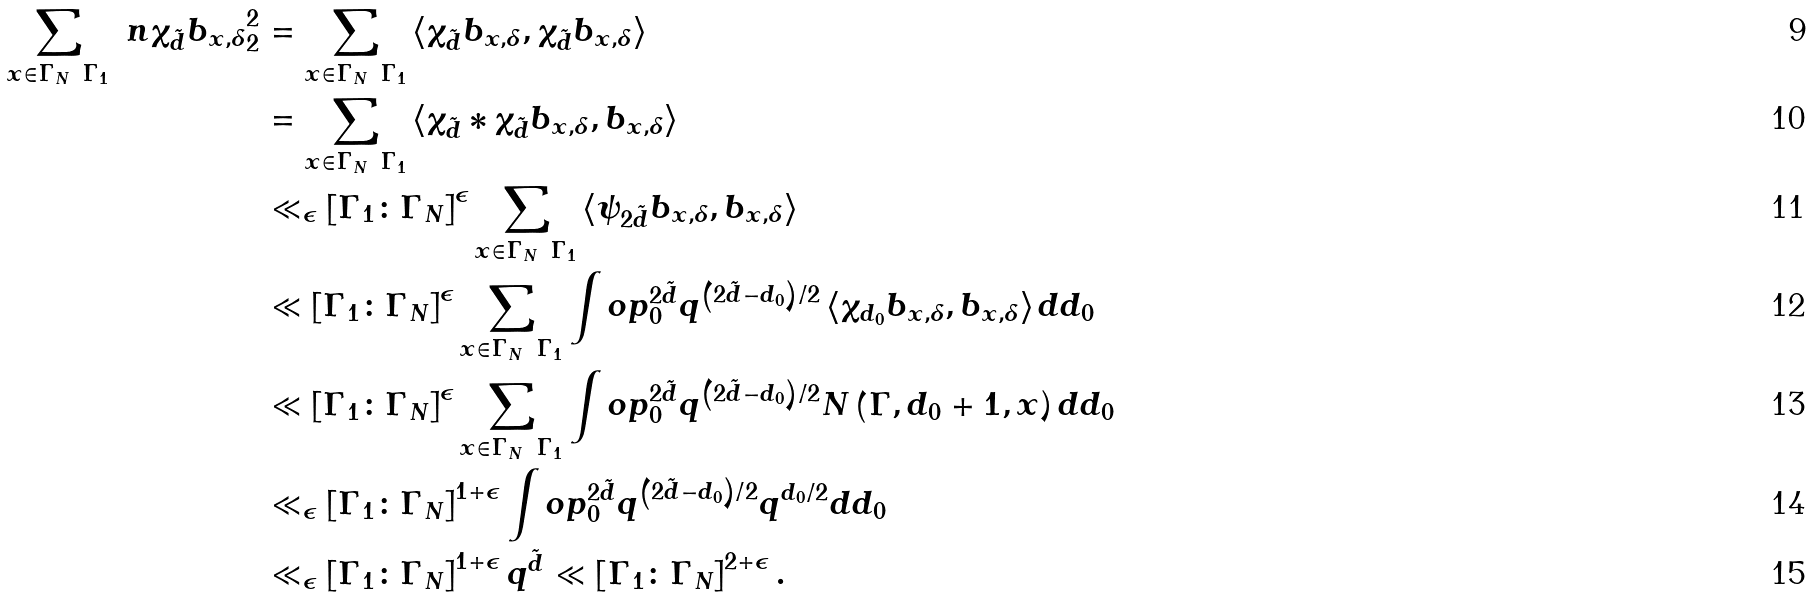<formula> <loc_0><loc_0><loc_500><loc_500>\sum _ { x \in \Gamma _ { N } \ \Gamma _ { 1 } } \ n { \chi _ { \tilde { d } } b _ { x , \delta } } _ { 2 } ^ { 2 } & = \sum _ { x \in \Gamma _ { N } \ \Gamma _ { 1 } } \left \langle \chi _ { \tilde { d } } b _ { x , \delta } , \chi _ { \tilde { d } } b _ { x , \delta } \right \rangle \\ & = \sum _ { x \in \Gamma _ { N } \ \Gamma _ { 1 } } \left \langle \chi _ { \tilde { d } } * \chi _ { \tilde { d } } b _ { x , \delta } , b _ { x , \delta } \right \rangle \\ & \ll _ { \epsilon } \left [ \Gamma _ { 1 } \colon \Gamma _ { N } \right ] ^ { \epsilon } \sum _ { x \in \Gamma _ { N } \ \Gamma _ { 1 } } \left \langle \psi _ { 2 \tilde { d } } b _ { x , \delta } , b _ { x , \delta } \right \rangle \\ & \ll \left [ \Gamma _ { 1 } \colon \Gamma _ { N } \right ] ^ { \epsilon } \sum _ { x \in \Gamma _ { N } \ \Gamma _ { 1 } } \int o p _ { 0 } ^ { 2 \tilde { d } } q ^ { \left ( 2 \tilde { d } - d _ { 0 } \right ) / 2 } \left \langle \chi _ { d _ { 0 } } b _ { x , \delta } , b _ { x , \delta } \right \rangle d d _ { 0 } \\ & \ll \left [ \Gamma _ { 1 } \colon \Gamma _ { N } \right ] ^ { \epsilon } \sum _ { x \in \Gamma _ { N } \ \Gamma _ { 1 } } \int o p _ { 0 } ^ { 2 \tilde { d } } q ^ { \left ( 2 \tilde { d } - d _ { 0 } \right ) / 2 } N \left ( \Gamma , d _ { 0 } + 1 , x \right ) d d _ { 0 } \\ & \ll _ { \epsilon } \left [ \Gamma _ { 1 } \colon \Gamma _ { N } \right ] ^ { 1 + \epsilon } \int o p _ { 0 } ^ { 2 \tilde { d } } q ^ { \left ( 2 \tilde { d } - d _ { 0 } \right ) / 2 } q ^ { d _ { 0 } / 2 } d d _ { 0 } \\ & \ll _ { \epsilon } \left [ \Gamma _ { 1 } \colon \Gamma _ { N } \right ] ^ { 1 + \epsilon } q ^ { \tilde { d } } \ll \left [ \Gamma _ { 1 } \colon \Gamma _ { N } \right ] ^ { 2 + \epsilon } .</formula> 